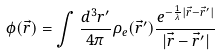Convert formula to latex. <formula><loc_0><loc_0><loc_500><loc_500>\phi ( { \vec { r } } ) = \int \frac { d ^ { 3 } r ^ { \prime } } { 4 \pi } \rho _ { e } ( { \vec { r } } ^ { \prime } ) \frac { e ^ { - { \frac { 1 } { \lambda } } | { \vec { r } } - { \vec { r } } ^ { \prime } | } } { | { \vec { r } } - { \vec { r } } ^ { \prime } | }</formula> 